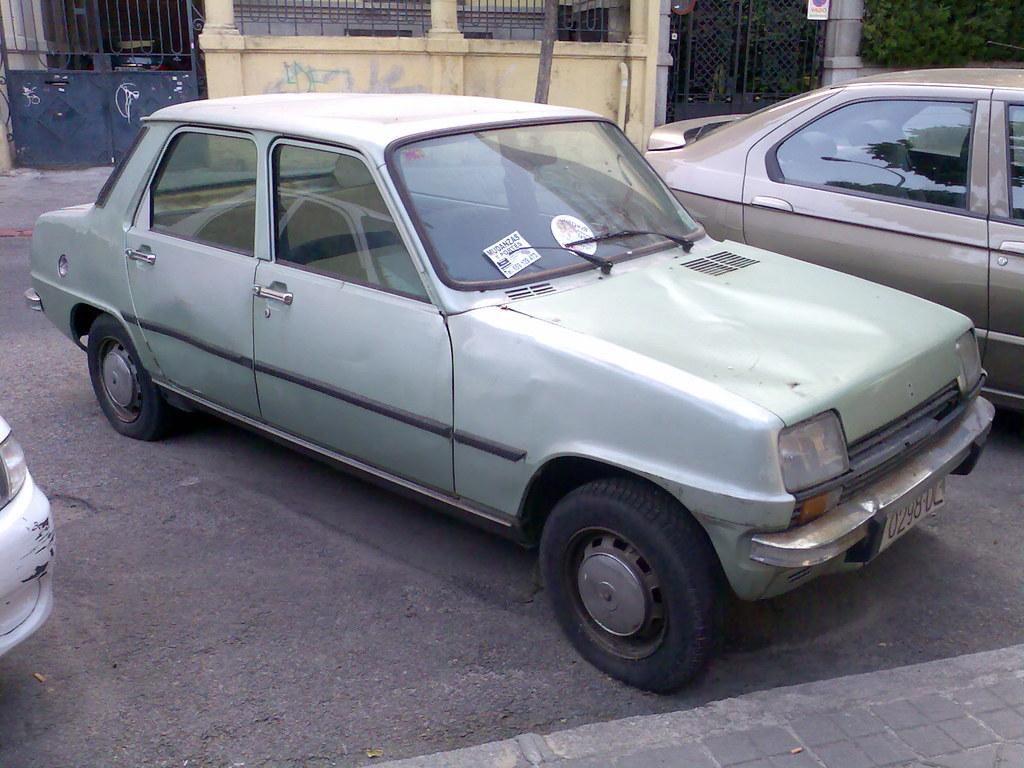What can be seen in the image? There are vehicles in the image. Can you describe the vehicles? The vehicles are in different colors. What is visible in the background of the image? There are buildings, gates, fencing, and green plants in the background of the image. What grade did the beetle receive on its recent exam in the image? There is no beetle or exam present in the image. Can you tell me what note the beetle is playing on the piano in the image? There is no beetle or piano present in the image. 